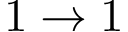Convert formula to latex. <formula><loc_0><loc_0><loc_500><loc_500>1 \rightarrow 1</formula> 